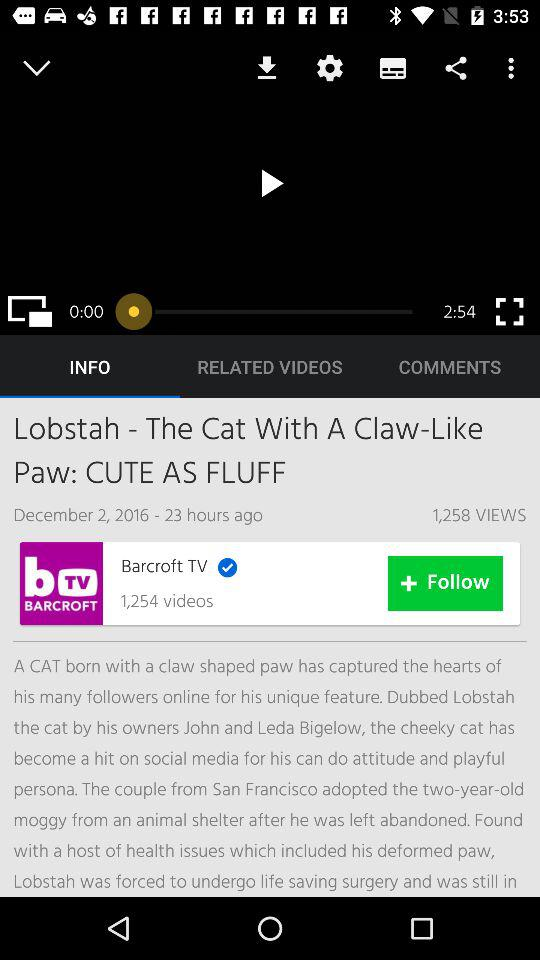How many videos have been uploaded to "Barcroft TV"? The number of videos uploaded to "Barcroft TV" is 1,254. 